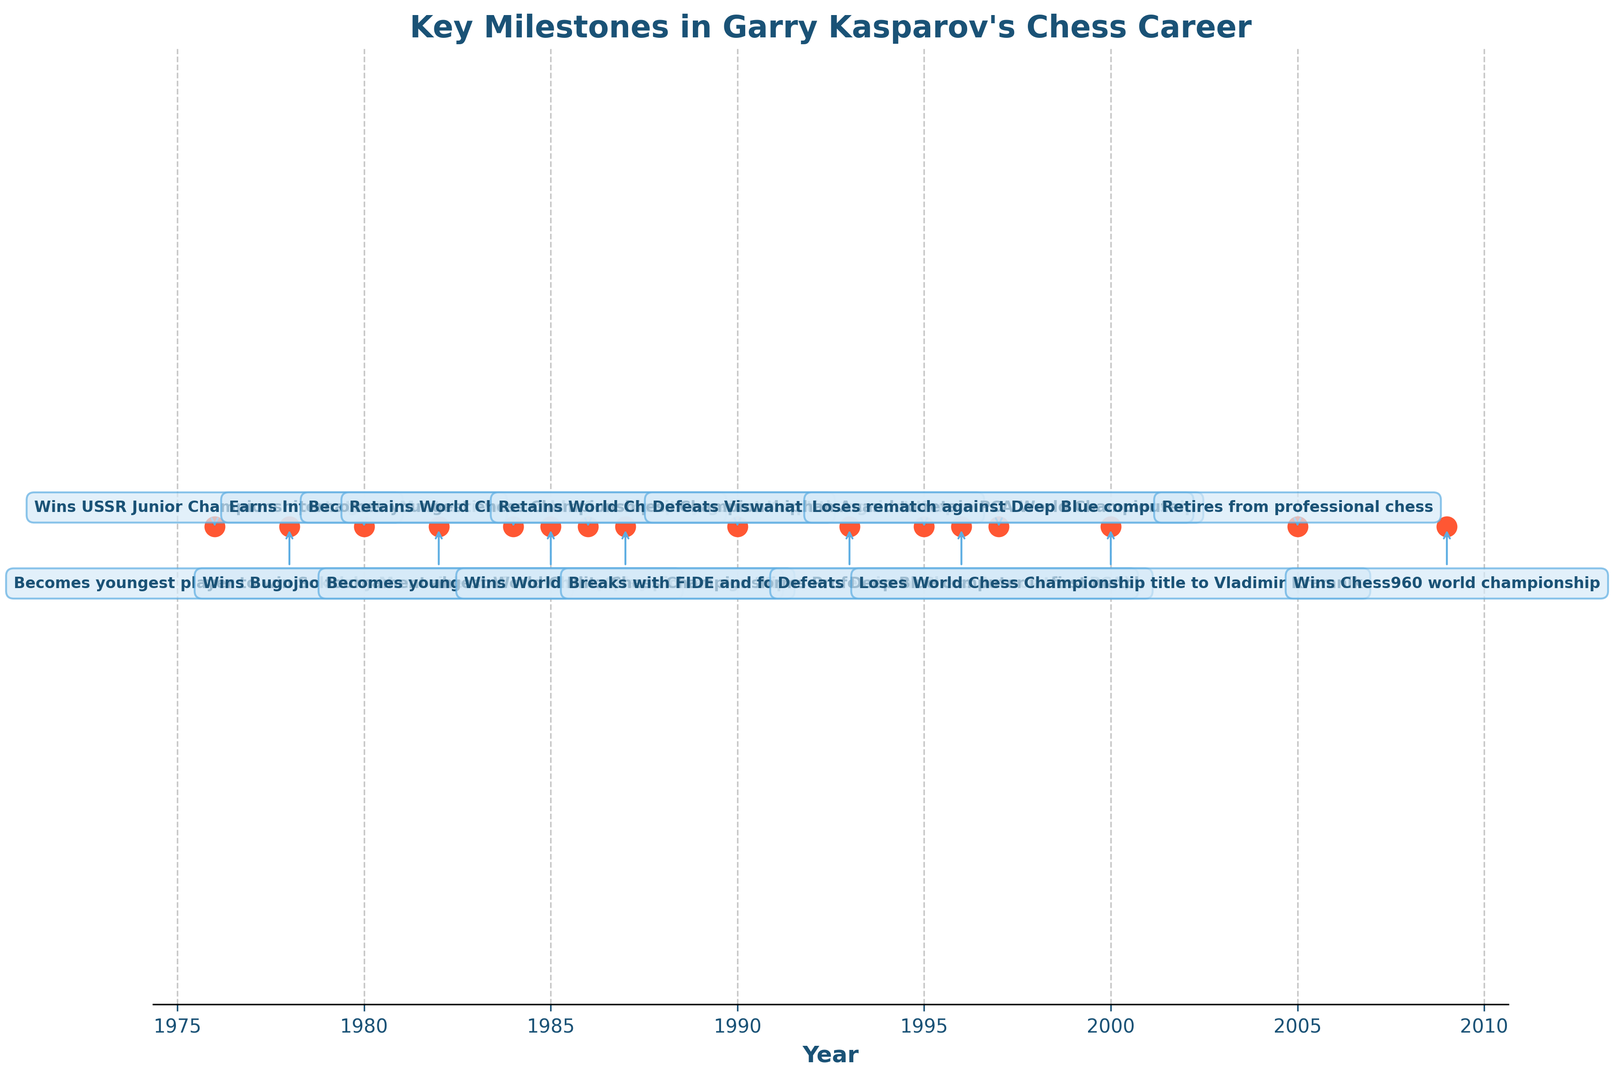What year did Garry Kasparov retire from professional chess? Locate the event description "Retires from professional chess" and its corresponding year on the plot.
Answer: 2005 Which event happened first, Kasparov defeating Deep Blue in the first match or losing to Vladimir Kramnik? Find both events on the plot. "Defeats Deep Blue computer in first match" occurred in 1996, and "Loses World Chess Championship title to Vladimir Kramnik" happened in 2000.
Answer: Defeats Deep Blue computer in first match What is the time gap between Kasparov becoming the youngest World Chess Champion and forming the Professional Chess Association (PCA)? Find the years when Kasparov became the youngest World Chess Champion (1985) and when he formed the PCA (1993). Subtract 1985 from 1993.
Answer: 8 years How many times did Kasparov retain the World Chess Championship title against Karpov? Look for events mentioning "Retains World Chess Championship title against Karpov" on the plot. There are two such events, in 1986 and 1990.
Answer: 2 times In which year did Kasparov achieve the title of International Master? Locate the event description "Earns International Master title" and its corresponding year on the plot.
Answer: 1980 Which event occurred later, Kasparov winning the Chess960 world championship or defeating Viswanathan Anand to retain PCA World Championship? Find both events on the plot. "Wins Chess960 world championship" occurred in 2009, and "Defeats Viswanathan Anand to retain PCA World Championship" happened in 1995.
Answer: Wins Chess960 world championship What is the longest time span between two consecutive events in Kasparov's career? Calculate the differences between each pair of consecutive years on the plot. The largest gap is between 2005 ("Retires from professional chess") and 2009 ("Wins Chess960 world championship"), which is 4 years.
Answer: 4 years Compare the frequency of events in Kasparov's career from 1980 to 1990 and from 1990 to 2000. Which period had more events? Count the number of events from 1980 to 1990 (6 events: 1980, 1982, 1984, 1985, 1986, 1990) and from 1990 to 2000 (5 events: 1990, 1993, 1995, 1996, 1997).
Answer: 1980 to 1990 Describe the visual appearance used to highlight the winning of the USSR Junior Championship by Garry Kasparov. Notice the color, marker size, and annotation box style for the event "Wins USSR Junior Championship at age 13" on the plot. It is marked with a red dot and has a blue text box for the annotation.
Answer: Red dot and blue text box What significant achievement did Kasparov accomplish in 1985? Locate the event description for the year 1985 on the plot.
Answer: Becomes youngest World Chess Champion at age 22 